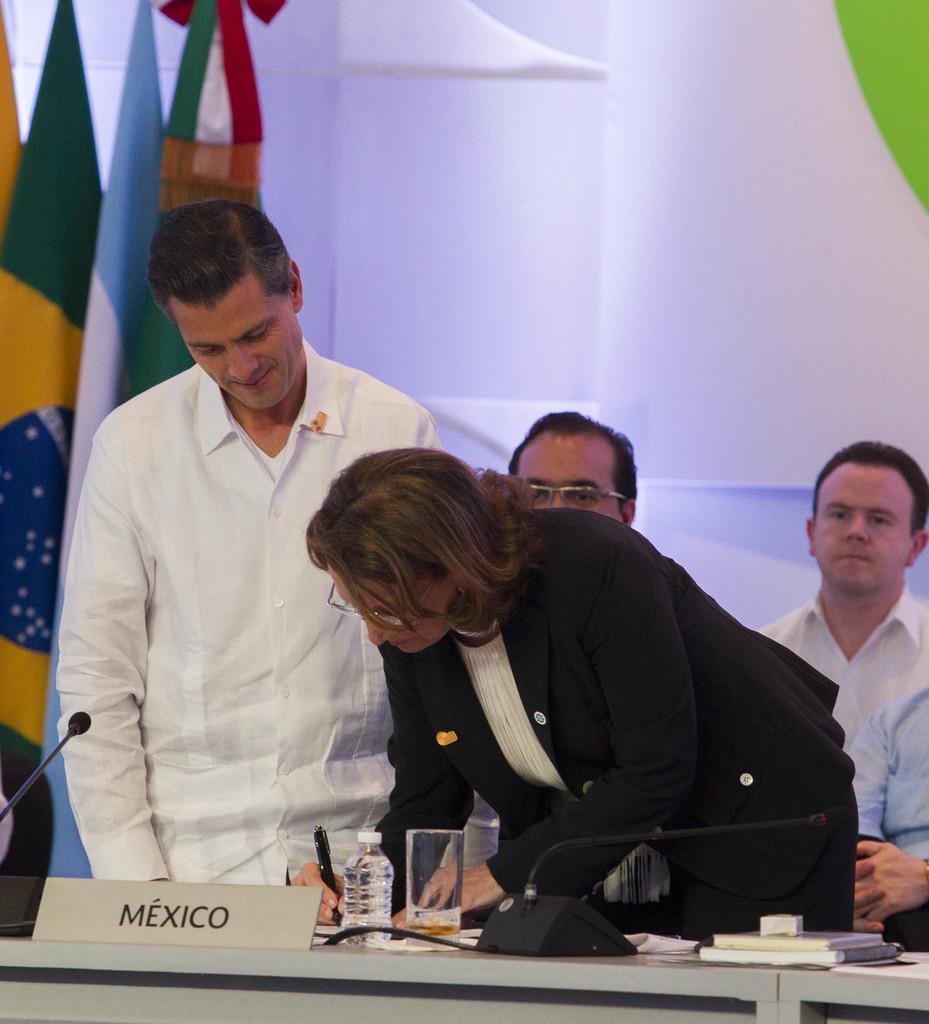Describe this image in one or two sentences. In this picture there are people in the center of the image and there is a table in front of them at the bottom side of the image, on which there are books and mice, there are flags on the left side of the image and there is a man in the center of the image, he is writing by placing his hands on the table. 